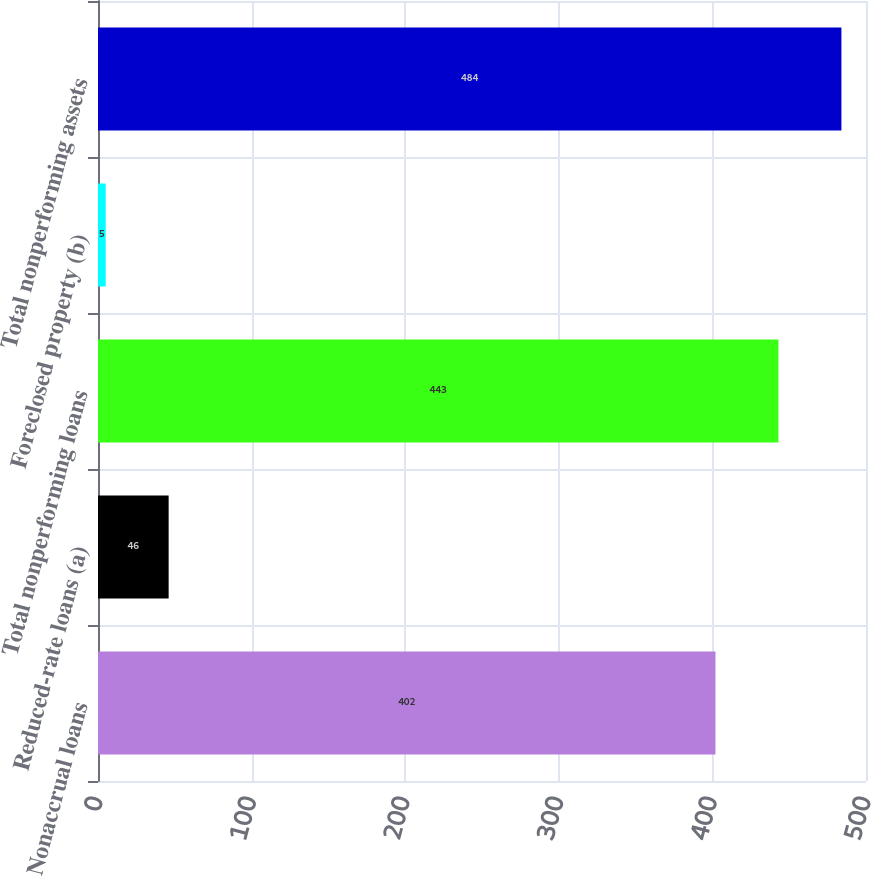Convert chart to OTSL. <chart><loc_0><loc_0><loc_500><loc_500><bar_chart><fcel>Nonaccrual loans<fcel>Reduced-rate loans (a)<fcel>Total nonperforming loans<fcel>Foreclosed property (b)<fcel>Total nonperforming assets<nl><fcel>402<fcel>46<fcel>443<fcel>5<fcel>484<nl></chart> 